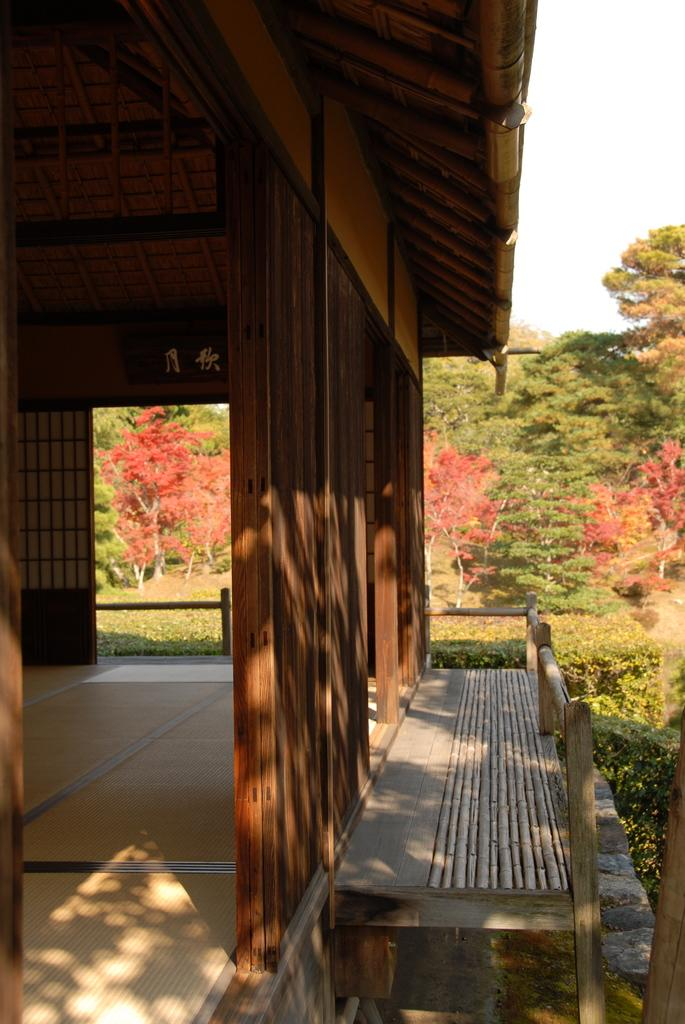What is the main structure visible in the foreground of the picture? There is a house in the foreground of the picture. What material is the house built with? The house is built with wood. What can be seen in the center of the picture? There are plants, flowers, and trees in the center of the picture. Where is the vase of flowers located in the image? There is no vase of flowers present in the image. What type of string is used to hold the tree branches together in the image? There is no string used to hold tree branches together in the image; the trees are naturally growing. 